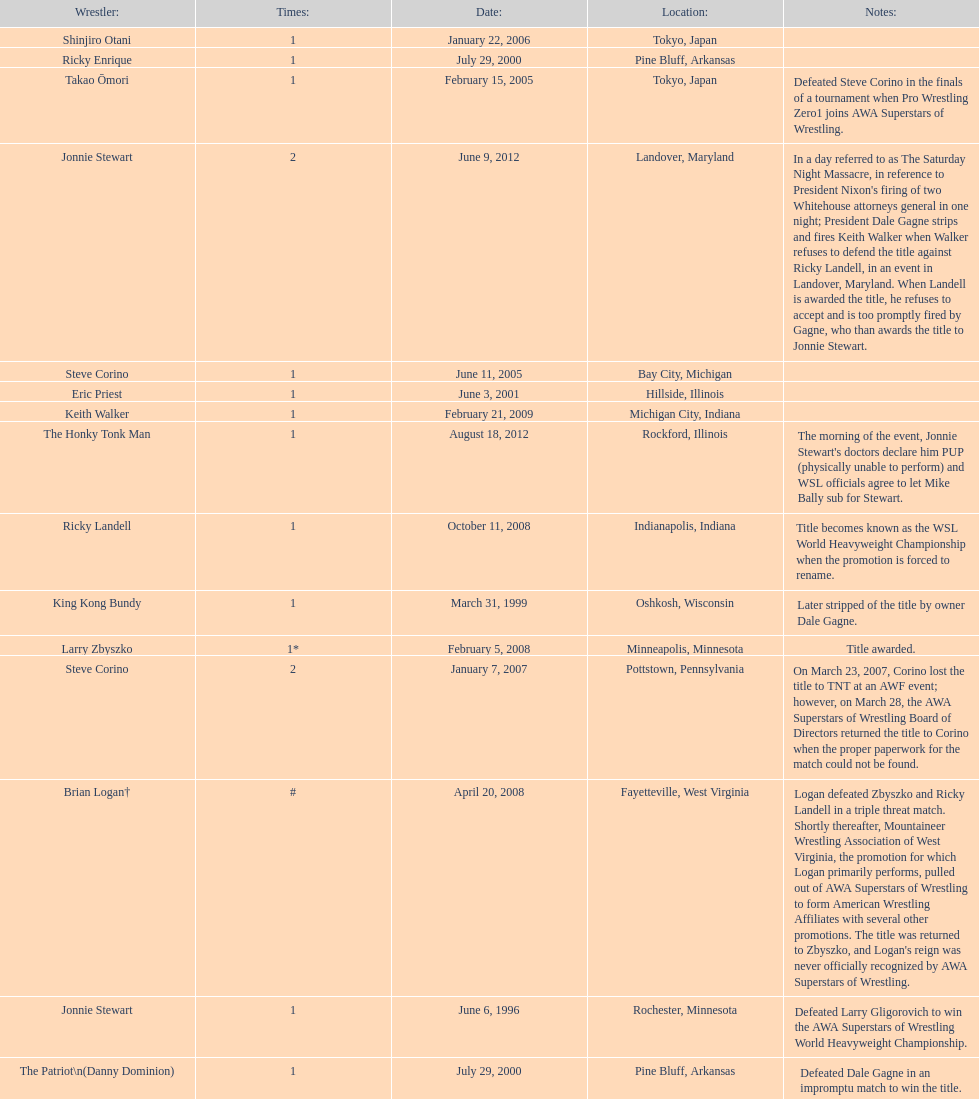How many different men held the wsl title before horshu won his first wsl title? 6. 